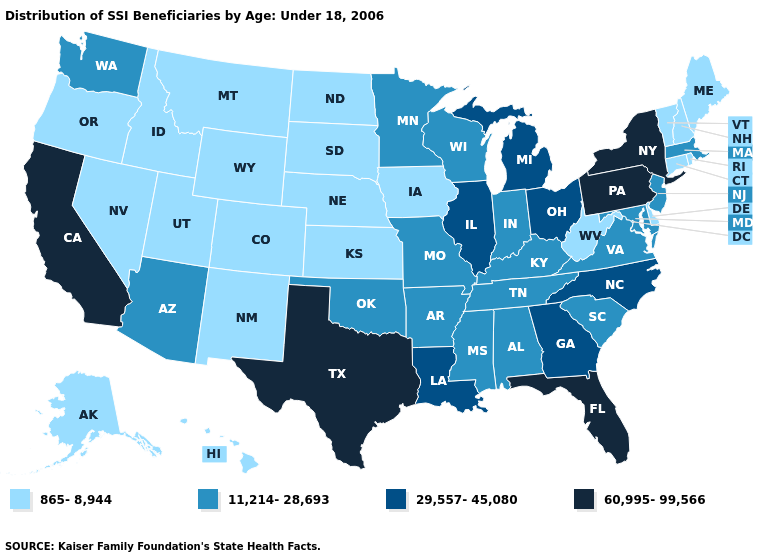Does Alabama have a higher value than South Carolina?
Answer briefly. No. Among the states that border Indiana , which have the highest value?
Concise answer only. Illinois, Michigan, Ohio. Does Maryland have the lowest value in the USA?
Keep it brief. No. What is the value of New Jersey?
Answer briefly. 11,214-28,693. Which states have the lowest value in the USA?
Be succinct. Alaska, Colorado, Connecticut, Delaware, Hawaii, Idaho, Iowa, Kansas, Maine, Montana, Nebraska, Nevada, New Hampshire, New Mexico, North Dakota, Oregon, Rhode Island, South Dakota, Utah, Vermont, West Virginia, Wyoming. Is the legend a continuous bar?
Be succinct. No. What is the value of Iowa?
Keep it brief. 865-8,944. What is the highest value in states that border Utah?
Answer briefly. 11,214-28,693. What is the value of Nebraska?
Short answer required. 865-8,944. What is the value of North Carolina?
Keep it brief. 29,557-45,080. Does the first symbol in the legend represent the smallest category?
Quick response, please. Yes. Name the states that have a value in the range 11,214-28,693?
Be succinct. Alabama, Arizona, Arkansas, Indiana, Kentucky, Maryland, Massachusetts, Minnesota, Mississippi, Missouri, New Jersey, Oklahoma, South Carolina, Tennessee, Virginia, Washington, Wisconsin. What is the highest value in the South ?
Quick response, please. 60,995-99,566. Which states have the highest value in the USA?
Be succinct. California, Florida, New York, Pennsylvania, Texas. Does the first symbol in the legend represent the smallest category?
Keep it brief. Yes. 